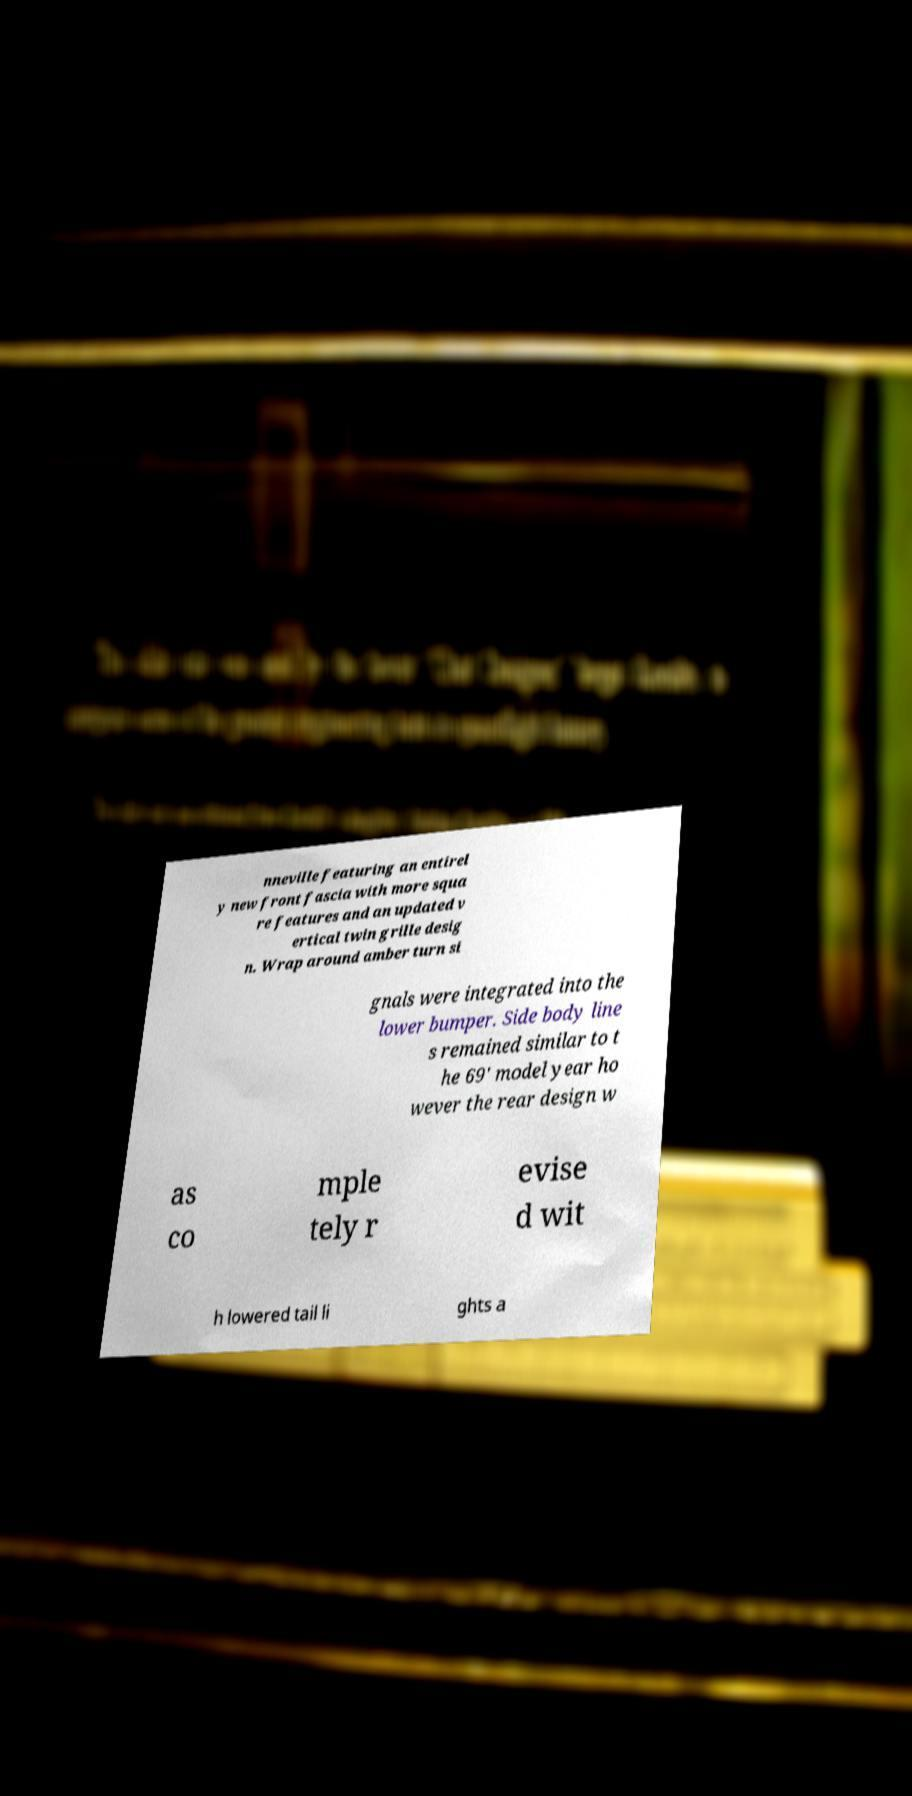Please identify and transcribe the text found in this image. nneville featuring an entirel y new front fascia with more squa re features and an updated v ertical twin grille desig n. Wrap around amber turn si gnals were integrated into the lower bumper. Side body line s remained similar to t he 69' model year ho wever the rear design w as co mple tely r evise d wit h lowered tail li ghts a 